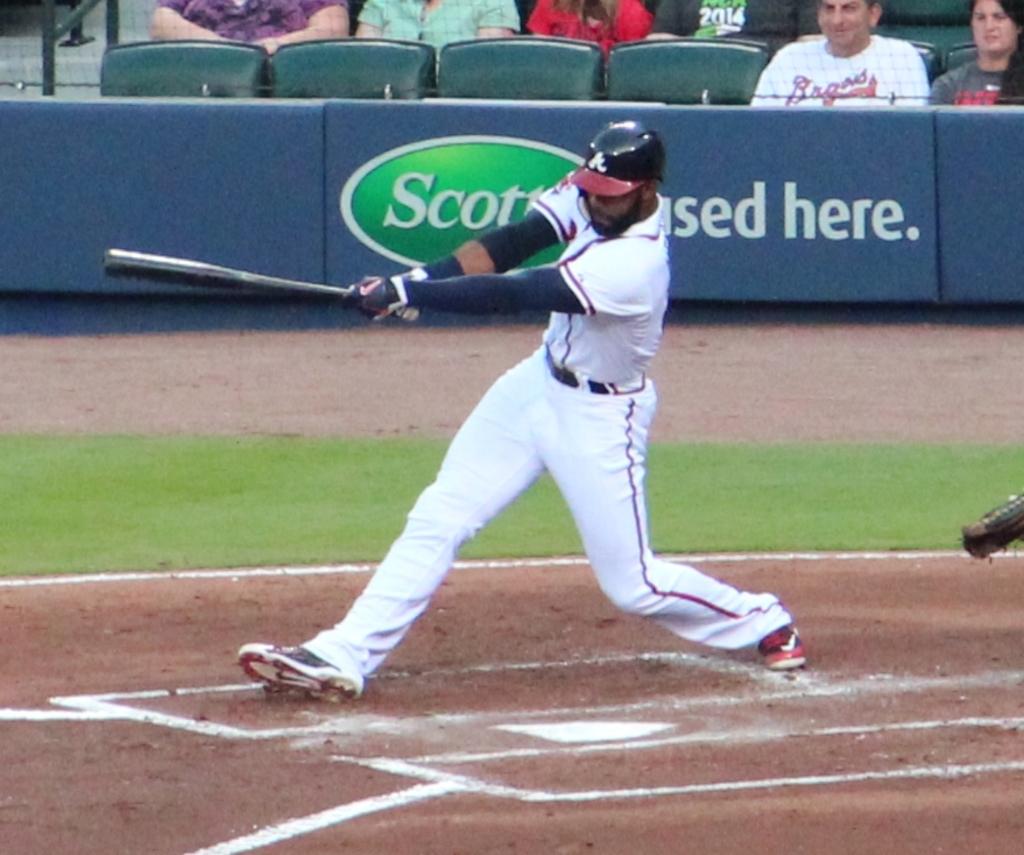What brand is used here?
Your answer should be very brief. Scotts. What letter is on the helmet?
Offer a very short reply. A. 